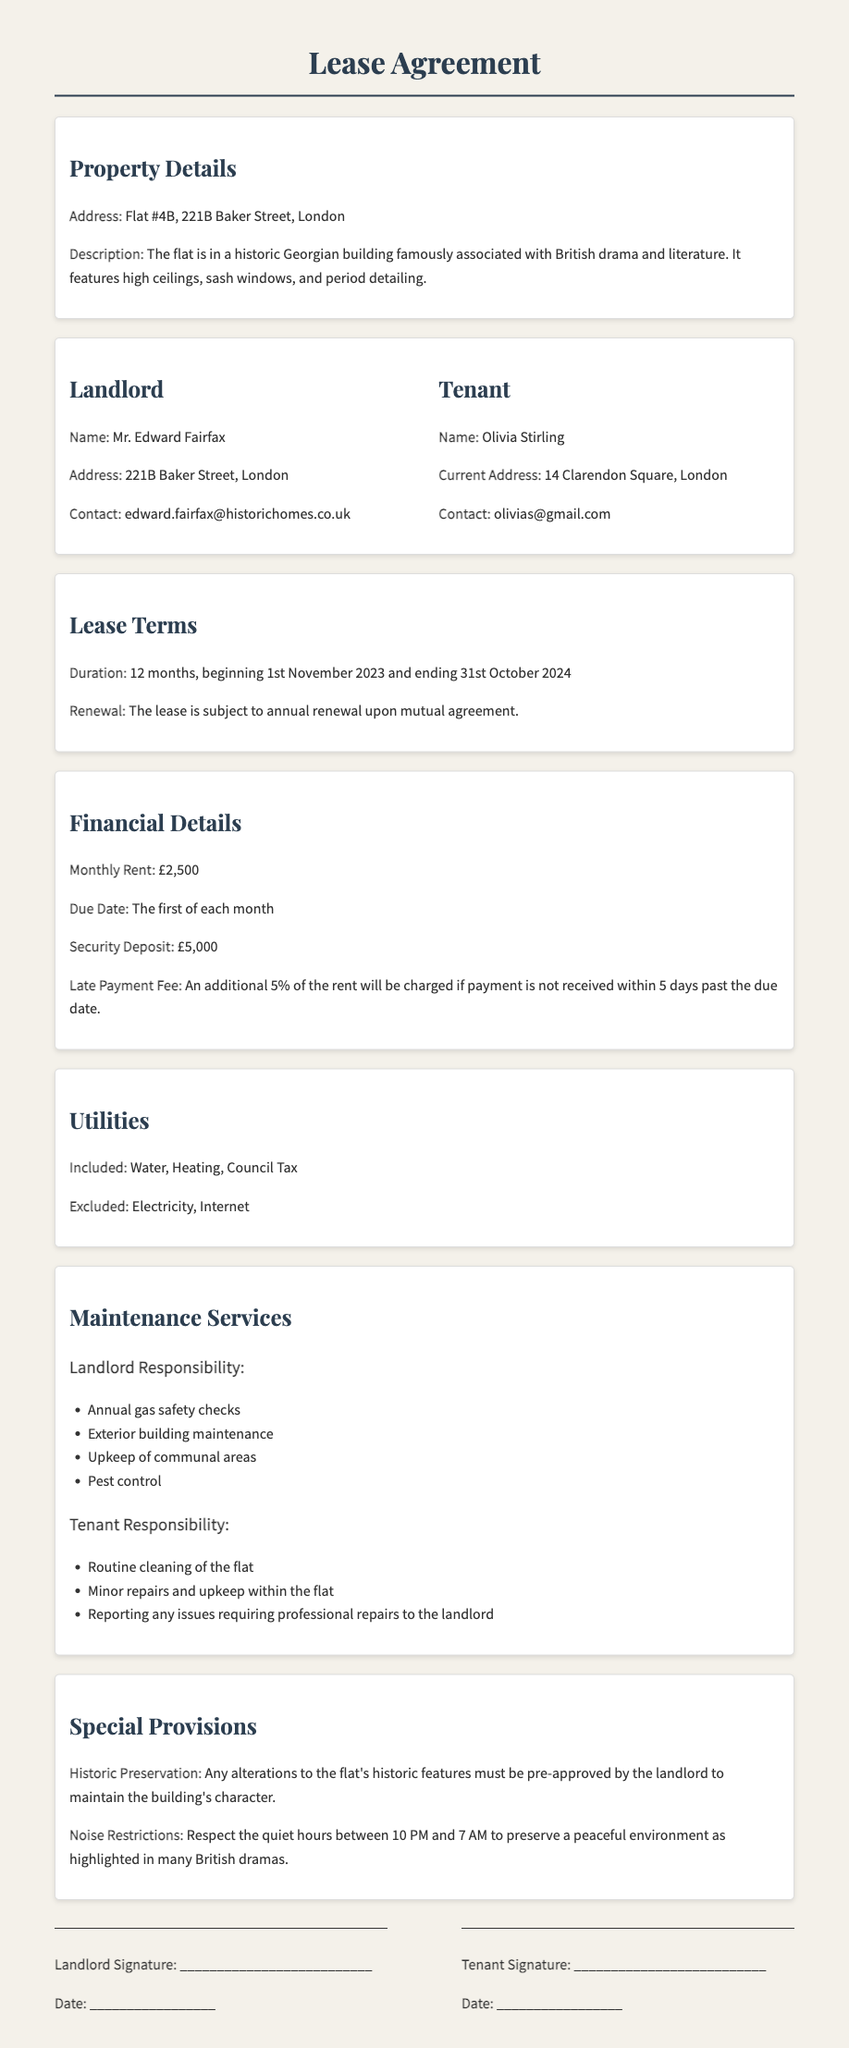What is the address of the flat? The address is provided in the Property Details section of the document.
Answer: Flat #4B, 221B Baker Street, London Who is the landlord? The name of the landlord can be found under the "Landlord" section.
Answer: Mr. Edward Fairfax What is the monthly rent? The monthly rent is specified in the Financial Details section.
Answer: £2,500 What utilities are included? The document outlines which utilities are included in the Utilities section.
Answer: Water, Heating, Council Tax What is the duration of the lease? The duration of the lease is clearly stated in the Lease Terms section.
Answer: 12 months What is required for alterations to the flat? The special provision for alterations is detailed in the Special Provisions section.
Answer: Pre-approved by the landlord What happens if rent is late? The consequences of late rent payments are outlined in the Financial Details section.
Answer: Additional 5% of the rent will be charged During what hours must noise be minimized? The noise restrictions specify the hours mentioned in the Special Provisions section.
Answer: Between 10 PM and 7 AM What are the tenant's responsibilities regarding maintenance? The responsibilities of the tenant are listed under Maintenance Services.
Answer: Routine cleaning of the flat 